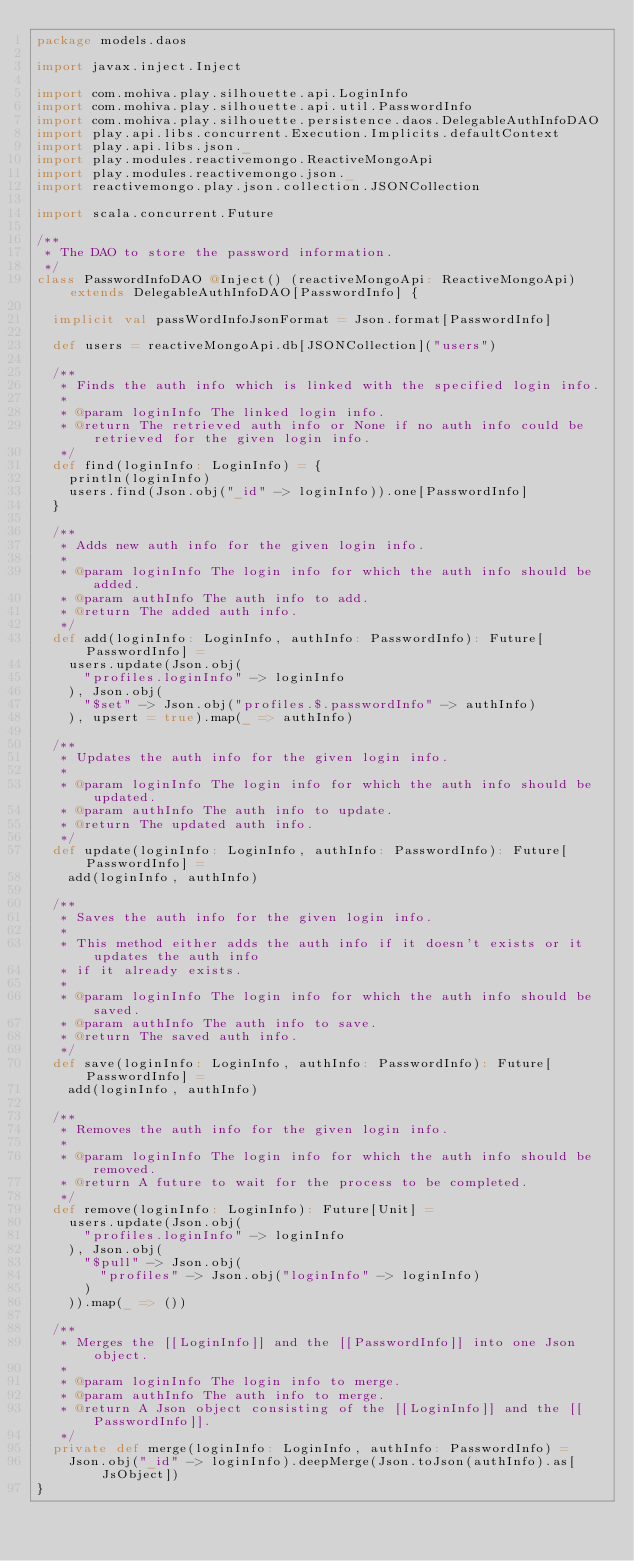Convert code to text. <code><loc_0><loc_0><loc_500><loc_500><_Scala_>package models.daos

import javax.inject.Inject

import com.mohiva.play.silhouette.api.LoginInfo
import com.mohiva.play.silhouette.api.util.PasswordInfo
import com.mohiva.play.silhouette.persistence.daos.DelegableAuthInfoDAO
import play.api.libs.concurrent.Execution.Implicits.defaultContext
import play.api.libs.json._
import play.modules.reactivemongo.ReactiveMongoApi
import play.modules.reactivemongo.json._
import reactivemongo.play.json.collection.JSONCollection

import scala.concurrent.Future

/**
 * The DAO to store the password information.
 */
class PasswordInfoDAO @Inject() (reactiveMongoApi: ReactiveMongoApi) extends DelegableAuthInfoDAO[PasswordInfo] {

  implicit val passWordInfoJsonFormat = Json.format[PasswordInfo]

  def users = reactiveMongoApi.db[JSONCollection]("users")

  /**
   * Finds the auth info which is linked with the specified login info.
   *
   * @param loginInfo The linked login info.
   * @return The retrieved auth info or None if no auth info could be retrieved for the given login info.
   */
  def find(loginInfo: LoginInfo) = {
    println(loginInfo)
    users.find(Json.obj("_id" -> loginInfo)).one[PasswordInfo]
  }

  /**
   * Adds new auth info for the given login info.
   *
   * @param loginInfo The login info for which the auth info should be added.
   * @param authInfo The auth info to add.
   * @return The added auth info.
   */
  def add(loginInfo: LoginInfo, authInfo: PasswordInfo): Future[PasswordInfo] =
    users.update(Json.obj(
      "profiles.loginInfo" -> loginInfo
    ), Json.obj(
      "$set" -> Json.obj("profiles.$.passwordInfo" -> authInfo)
    ), upsert = true).map(_ => authInfo)

  /**
   * Updates the auth info for the given login info.
   *
   * @param loginInfo The login info for which the auth info should be updated.
   * @param authInfo The auth info to update.
   * @return The updated auth info.
   */
  def update(loginInfo: LoginInfo, authInfo: PasswordInfo): Future[PasswordInfo] =
    add(loginInfo, authInfo)

  /**
   * Saves the auth info for the given login info.
   *
   * This method either adds the auth info if it doesn't exists or it updates the auth info
   * if it already exists.
   *
   * @param loginInfo The login info for which the auth info should be saved.
   * @param authInfo The auth info to save.
   * @return The saved auth info.
   */
  def save(loginInfo: LoginInfo, authInfo: PasswordInfo): Future[PasswordInfo] =
    add(loginInfo, authInfo)

  /**
   * Removes the auth info for the given login info.
   *
   * @param loginInfo The login info for which the auth info should be removed.
   * @return A future to wait for the process to be completed.
   */
  def remove(loginInfo: LoginInfo): Future[Unit] =
    users.update(Json.obj(
      "profiles.loginInfo" -> loginInfo
    ), Json.obj(
      "$pull" -> Json.obj(
        "profiles" -> Json.obj("loginInfo" -> loginInfo)
      )
    )).map(_ => ())

  /**
   * Merges the [[LoginInfo]] and the [[PasswordInfo]] into one Json object.
   *
   * @param loginInfo The login info to merge.
   * @param authInfo The auth info to merge.
   * @return A Json object consisting of the [[LoginInfo]] and the [[PasswordInfo]].
   */
  private def merge(loginInfo: LoginInfo, authInfo: PasswordInfo) =
    Json.obj("_id" -> loginInfo).deepMerge(Json.toJson(authInfo).as[JsObject])
}
</code> 